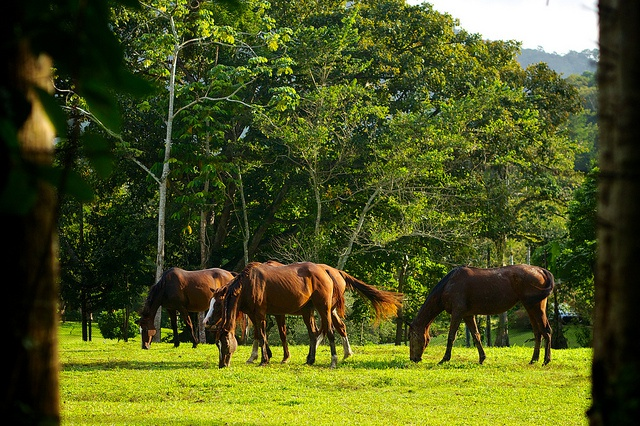Describe the objects in this image and their specific colors. I can see horse in black, maroon, olive, and brown tones, horse in black, maroon, and brown tones, horse in black, maroon, brown, and gray tones, and horse in black, olive, and maroon tones in this image. 